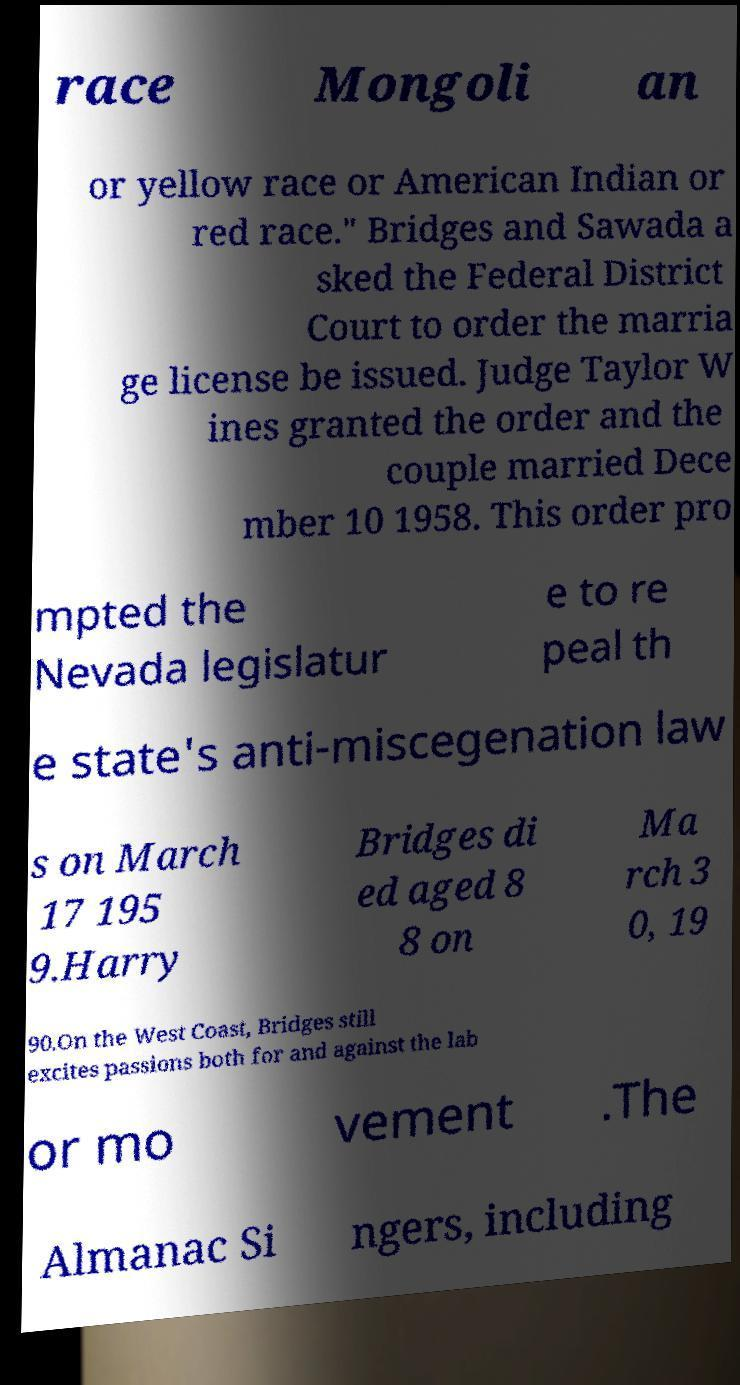Could you assist in decoding the text presented in this image and type it out clearly? race Mongoli an or yellow race or American Indian or red race." Bridges and Sawada a sked the Federal District Court to order the marria ge license be issued. Judge Taylor W ines granted the order and the couple married Dece mber 10 1958. This order pro mpted the Nevada legislatur e to re peal th e state's anti-miscegenation law s on March 17 195 9.Harry Bridges di ed aged 8 8 on Ma rch 3 0, 19 90.On the West Coast, Bridges still excites passions both for and against the lab or mo vement .The Almanac Si ngers, including 